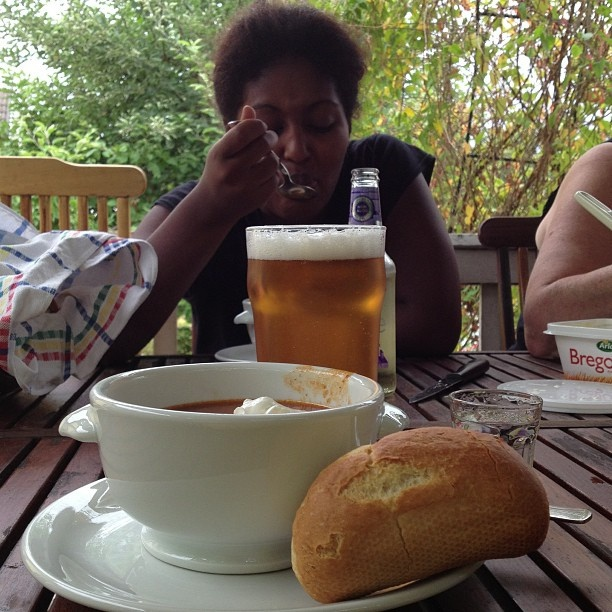Describe the objects in this image and their specific colors. I can see dining table in white, gray, maroon, darkgray, and black tones, people in white, black, gray, maroon, and olive tones, bowl in white, gray, and darkgray tones, cup in white, maroon, darkgray, and lightgray tones, and people in white, maroon, darkgray, gray, and brown tones in this image. 